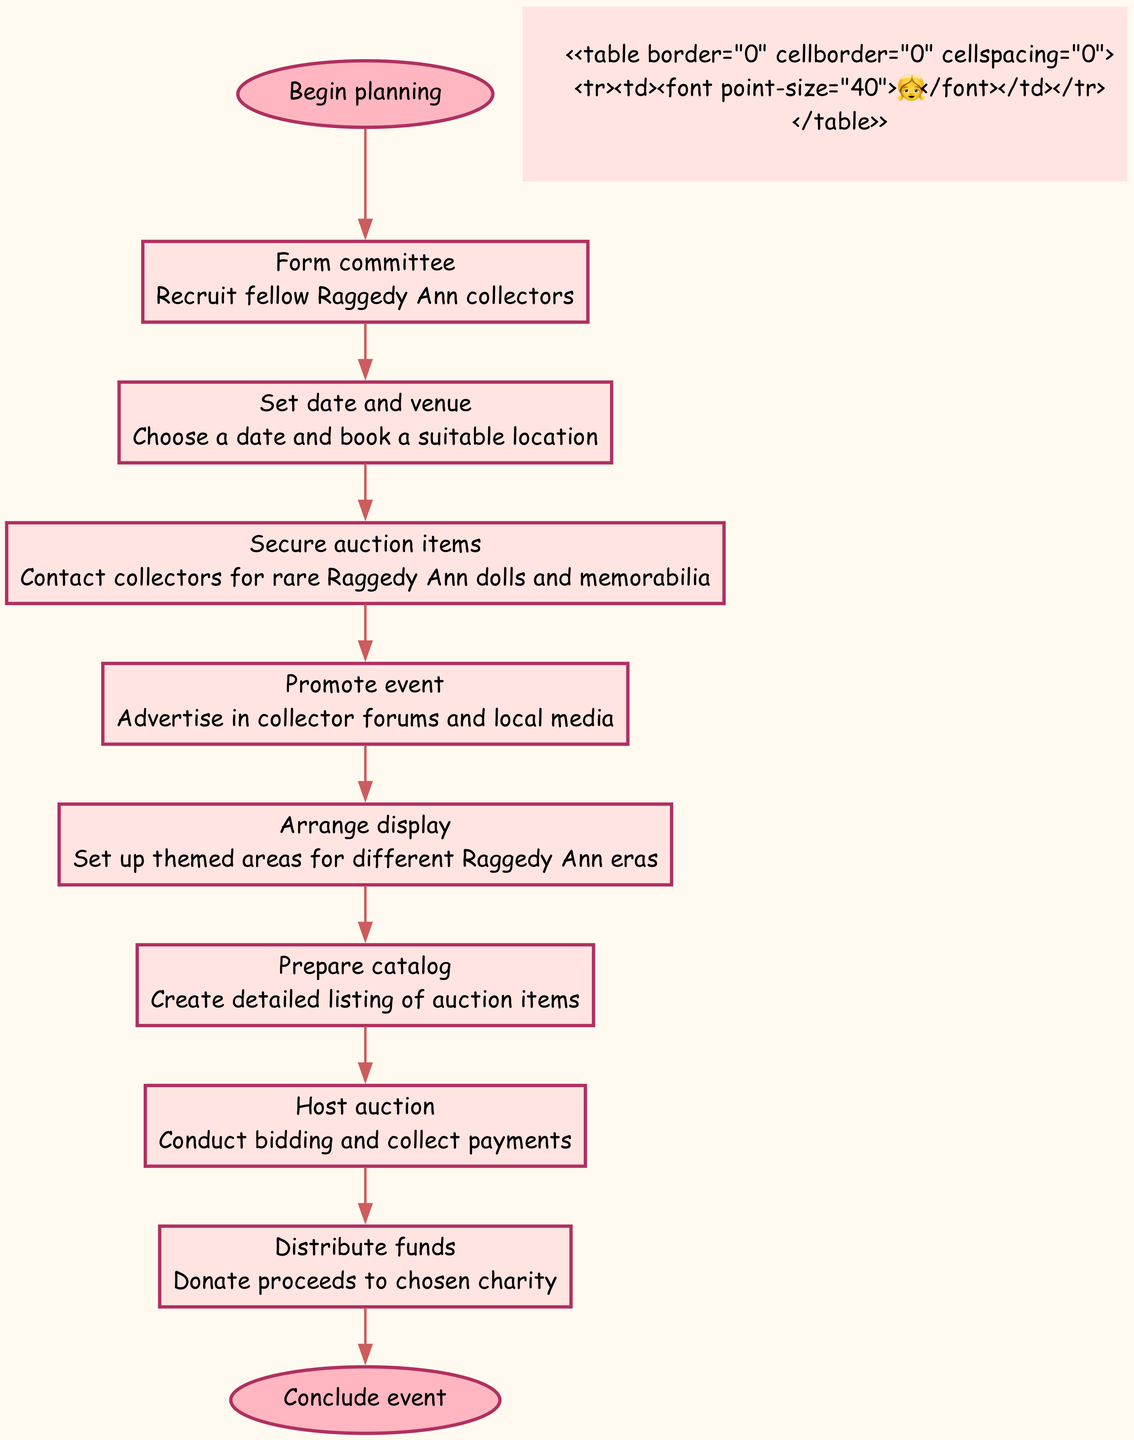What is the first step in the auction planning process? The diagram starts with the node labeled "Begin planning," which indicates the initial action to start organizing the charity auction. The next node connected to this starting point is "Form committee."
Answer: Form committee How many steps are there in organizing the auction? By counting the distinct steps listed in the diagram, we find that there are a total of eight numbered steps that detail the process of organizing the charity auction.
Answer: Eight What is the last step in the charity auction process? The final node before reaching the conclusion of the diagram is labeled "Distribute funds," which leads to the concluding action marked as "Conclude event."
Answer: Distribute funds Which step comes immediately after securing auction items? Referring to the diagram, the step labeled "Secure auction items" is followed directly by the node labeled "Promote event," indicating the next action to be taken in the flowchart.
Answer: Promote event Which node has the details about contacting collectors? The step "Secure auction items" clearly states the action of contacting collectors for rare Raggedy Ann dolls and memorabilia, highlighted as the detail under this node.
Answer: Secure auction items What is the connection between promoting the event and hosting the auction? The connection indicates the sequence in the diagram, where "Promote event" leads to "Host auction." This implies that advertising and awareness efforts are expected to be completed prior to conducting the auction.
Answer: Promotion leads to hosting What action needs to be taken before arranging the display? According to the flowchart, "Promote event" must be completed before one can proceed to "Arrange display," suggesting that event promotion is a prerequisite.
Answer: Promote event What is the purpose of the fundraiser as shown in the flowchart? The final step in the process, "Distribute funds," indicates that the proceeds from the auction are to be donated to a chosen charity, which signifies the overall purpose of the event.
Answer: Donate proceeds to chosen charity 